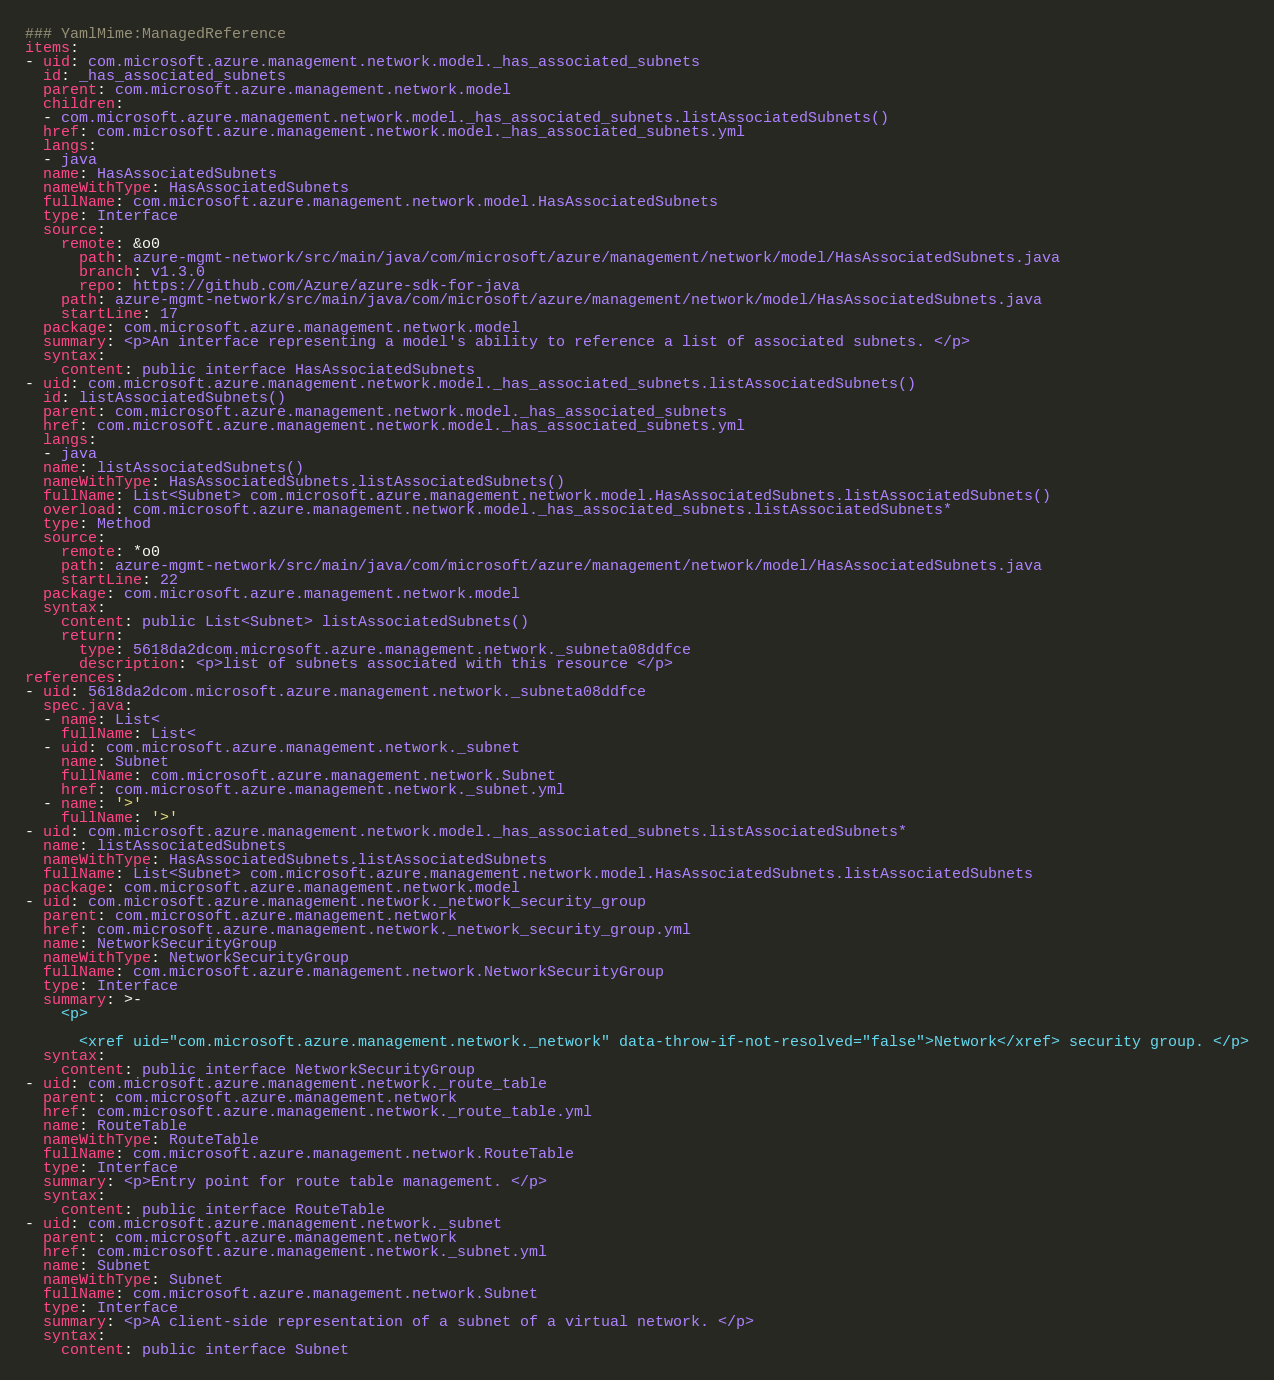Convert code to text. <code><loc_0><loc_0><loc_500><loc_500><_YAML_>### YamlMime:ManagedReference
items:
- uid: com.microsoft.azure.management.network.model._has_associated_subnets
  id: _has_associated_subnets
  parent: com.microsoft.azure.management.network.model
  children:
  - com.microsoft.azure.management.network.model._has_associated_subnets.listAssociatedSubnets()
  href: com.microsoft.azure.management.network.model._has_associated_subnets.yml
  langs:
  - java
  name: HasAssociatedSubnets
  nameWithType: HasAssociatedSubnets
  fullName: com.microsoft.azure.management.network.model.HasAssociatedSubnets
  type: Interface
  source:
    remote: &o0
      path: azure-mgmt-network/src/main/java/com/microsoft/azure/management/network/model/HasAssociatedSubnets.java
      branch: v1.3.0
      repo: https://github.com/Azure/azure-sdk-for-java
    path: azure-mgmt-network/src/main/java/com/microsoft/azure/management/network/model/HasAssociatedSubnets.java
    startLine: 17
  package: com.microsoft.azure.management.network.model
  summary: <p>An interface representing a model's ability to reference a list of associated subnets. </p>
  syntax:
    content: public interface HasAssociatedSubnets
- uid: com.microsoft.azure.management.network.model._has_associated_subnets.listAssociatedSubnets()
  id: listAssociatedSubnets()
  parent: com.microsoft.azure.management.network.model._has_associated_subnets
  href: com.microsoft.azure.management.network.model._has_associated_subnets.yml
  langs:
  - java
  name: listAssociatedSubnets()
  nameWithType: HasAssociatedSubnets.listAssociatedSubnets()
  fullName: List<Subnet> com.microsoft.azure.management.network.model.HasAssociatedSubnets.listAssociatedSubnets()
  overload: com.microsoft.azure.management.network.model._has_associated_subnets.listAssociatedSubnets*
  type: Method
  source:
    remote: *o0
    path: azure-mgmt-network/src/main/java/com/microsoft/azure/management/network/model/HasAssociatedSubnets.java
    startLine: 22
  package: com.microsoft.azure.management.network.model
  syntax:
    content: public List<Subnet> listAssociatedSubnets()
    return:
      type: 5618da2dcom.microsoft.azure.management.network._subneta08ddfce
      description: <p>list of subnets associated with this resource </p>
references:
- uid: 5618da2dcom.microsoft.azure.management.network._subneta08ddfce
  spec.java:
  - name: List<
    fullName: List<
  - uid: com.microsoft.azure.management.network._subnet
    name: Subnet
    fullName: com.microsoft.azure.management.network.Subnet
    href: com.microsoft.azure.management.network._subnet.yml
  - name: '>'
    fullName: '>'
- uid: com.microsoft.azure.management.network.model._has_associated_subnets.listAssociatedSubnets*
  name: listAssociatedSubnets
  nameWithType: HasAssociatedSubnets.listAssociatedSubnets
  fullName: List<Subnet> com.microsoft.azure.management.network.model.HasAssociatedSubnets.listAssociatedSubnets
  package: com.microsoft.azure.management.network.model
- uid: com.microsoft.azure.management.network._network_security_group
  parent: com.microsoft.azure.management.network
  href: com.microsoft.azure.management.network._network_security_group.yml
  name: NetworkSecurityGroup
  nameWithType: NetworkSecurityGroup
  fullName: com.microsoft.azure.management.network.NetworkSecurityGroup
  type: Interface
  summary: >-
    <p>

      <xref uid="com.microsoft.azure.management.network._network" data-throw-if-not-resolved="false">Network</xref> security group. </p>
  syntax:
    content: public interface NetworkSecurityGroup
- uid: com.microsoft.azure.management.network._route_table
  parent: com.microsoft.azure.management.network
  href: com.microsoft.azure.management.network._route_table.yml
  name: RouteTable
  nameWithType: RouteTable
  fullName: com.microsoft.azure.management.network.RouteTable
  type: Interface
  summary: <p>Entry point for route table management. </p>
  syntax:
    content: public interface RouteTable
- uid: com.microsoft.azure.management.network._subnet
  parent: com.microsoft.azure.management.network
  href: com.microsoft.azure.management.network._subnet.yml
  name: Subnet
  nameWithType: Subnet
  fullName: com.microsoft.azure.management.network.Subnet
  type: Interface
  summary: <p>A client-side representation of a subnet of a virtual network. </p>
  syntax:
    content: public interface Subnet
</code> 